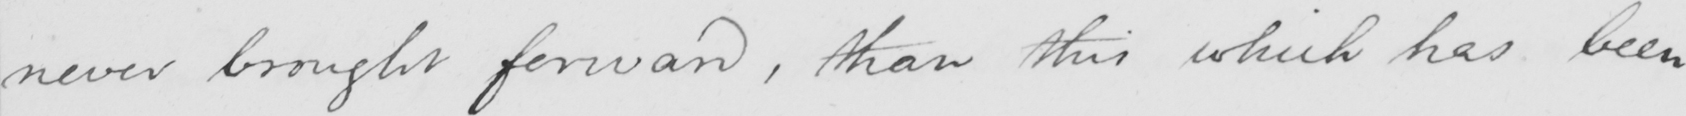Please transcribe the handwritten text in this image. never brought forward , than this which has been 